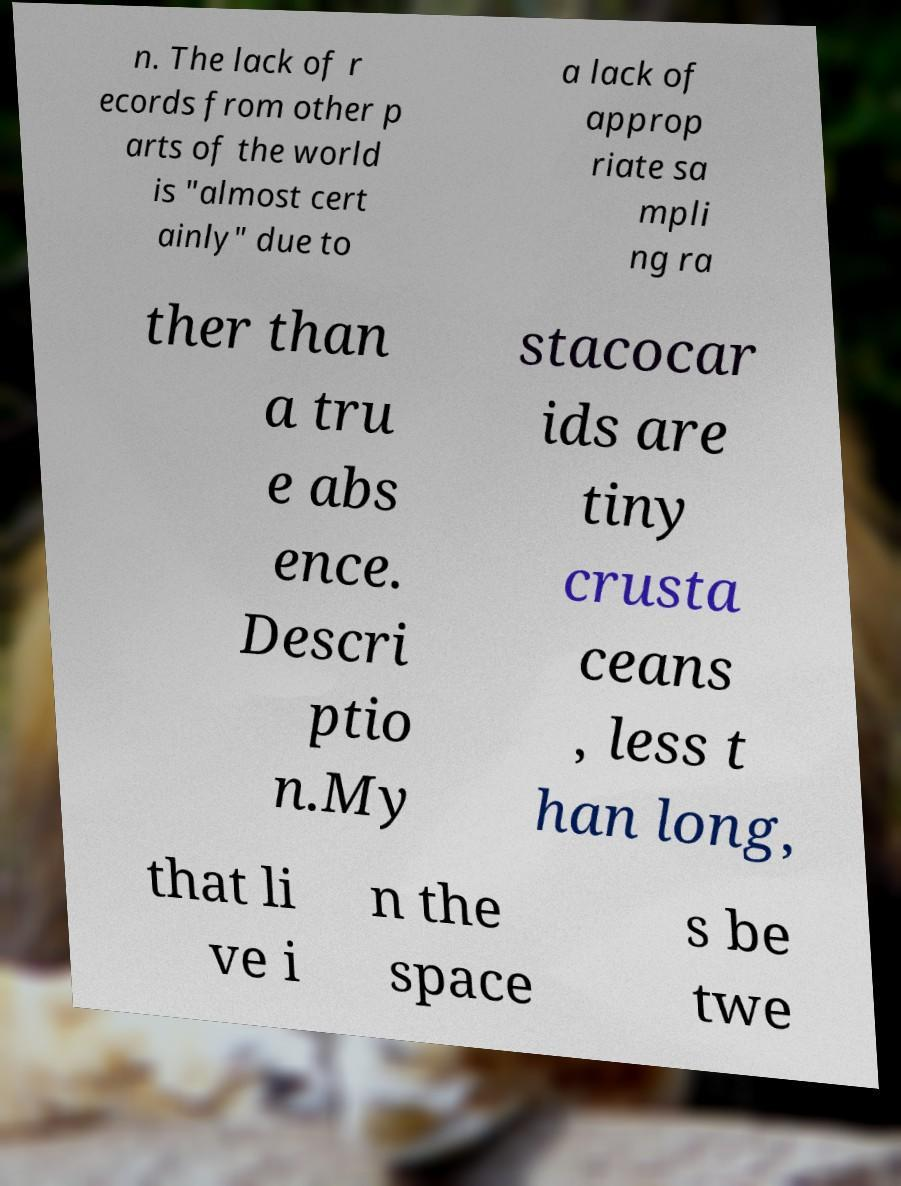Please identify and transcribe the text found in this image. n. The lack of r ecords from other p arts of the world is "almost cert ainly" due to a lack of approp riate sa mpli ng ra ther than a tru e abs ence. Descri ptio n.My stacocar ids are tiny crusta ceans , less t han long, that li ve i n the space s be twe 